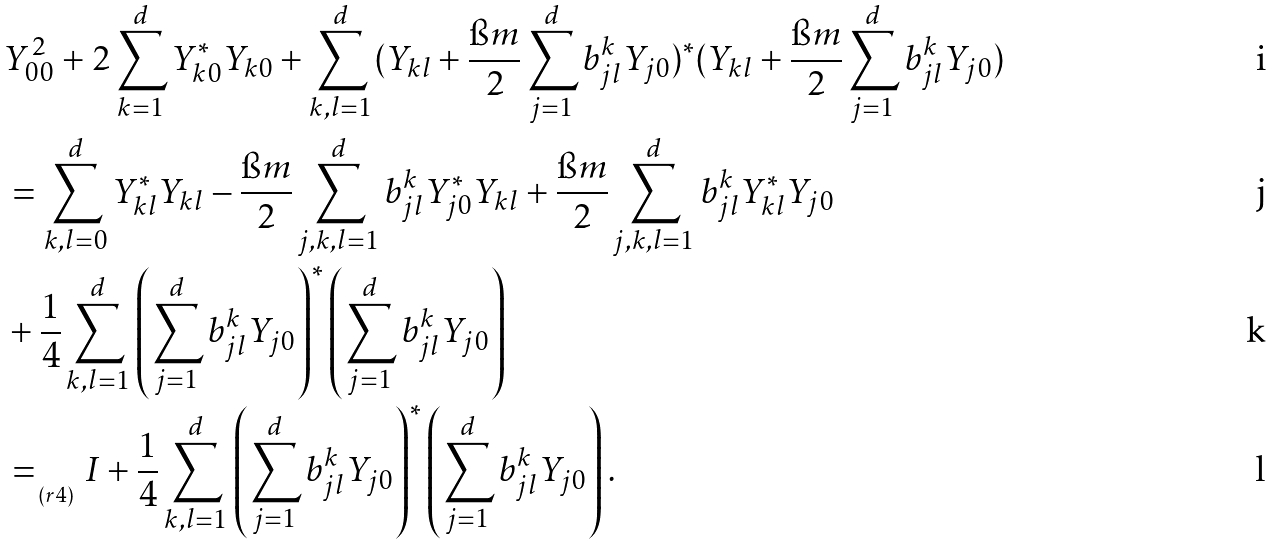<formula> <loc_0><loc_0><loc_500><loc_500>& Y ^ { 2 } _ { 0 0 } + 2 \sum ^ { d } _ { k = 1 } Y ^ { \ast } _ { k 0 } Y _ { k 0 } + \sum ^ { d } _ { k , l = 1 } ( Y _ { k l } + \frac { \i m } { 2 } \sum ^ { d } _ { j = 1 } b ^ { k } _ { j l } Y _ { j 0 } ) ^ { \ast } ( Y _ { k l } + \frac { \i m } { 2 } \sum ^ { d } _ { j = 1 } b ^ { k } _ { j l } Y _ { j 0 } ) \\ & = \sum ^ { d } _ { k , l = 0 } Y ^ { \ast } _ { k l } Y _ { k l } - \frac { \i m } { 2 } \sum ^ { d } _ { j , k , l = 1 } b ^ { k } _ { j l } Y ^ { \ast } _ { j 0 } Y _ { k l } + \frac { \i m } { 2 } \sum ^ { d } _ { j , k , l = 1 } b ^ { k } _ { j l } Y ^ { \ast } _ { k l } Y _ { j 0 } \\ & + \frac { 1 } { 4 } \sum ^ { d } _ { k , l = 1 } \left ( \sum ^ { d } _ { j = 1 } b ^ { k } _ { j l } Y _ { j 0 } \right ) ^ { \ast } \left ( \sum ^ { d } _ { j = 1 } b ^ { k } _ { j l } Y _ { j 0 } \right ) \\ & = _ { _ { _ { \, ( r 4 ) } } } I + \frac { 1 } { 4 } \sum ^ { d } _ { k , l = 1 } \left ( \sum ^ { d } _ { j = 1 } b ^ { k } _ { j l } Y _ { j 0 } \right ) ^ { \ast } \left ( \sum ^ { d } _ { j = 1 } b ^ { k } _ { j l } Y _ { j 0 } \right ) .</formula> 